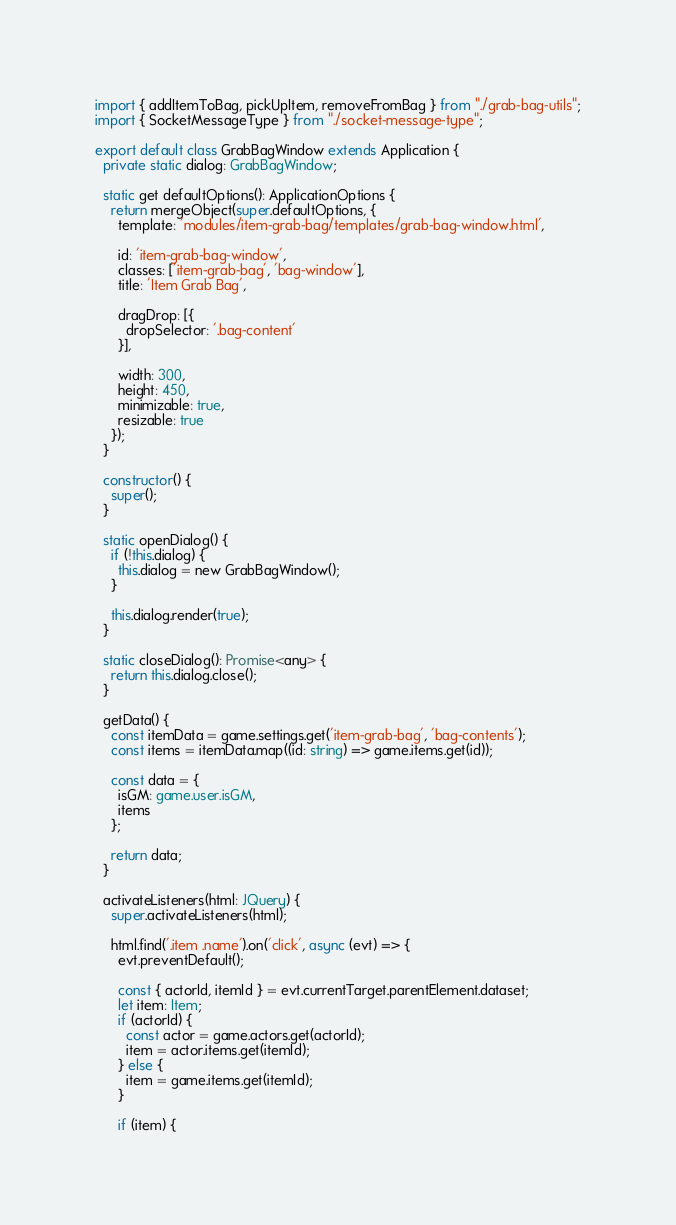Convert code to text. <code><loc_0><loc_0><loc_500><loc_500><_TypeScript_>import { addItemToBag, pickUpItem, removeFromBag } from "./grab-bag-utils";
import { SocketMessageType } from "./socket-message-type";

export default class GrabBagWindow extends Application {
  private static dialog: GrabBagWindow;

  static get defaultOptions(): ApplicationOptions {
    return mergeObject(super.defaultOptions, {
      template: 'modules/item-grab-bag/templates/grab-bag-window.html',

      id: 'item-grab-bag-window',
      classes: ['item-grab-bag', 'bag-window'],
      title: 'Item Grab Bag',

      dragDrop: [{
        dropSelector: '.bag-content'
      }],

      width: 300,
      height: 450,
      minimizable: true,
      resizable: true
    });
  }

  constructor() {
    super();
  }

  static openDialog() {
    if (!this.dialog) {
      this.dialog = new GrabBagWindow();
    }

    this.dialog.render(true);
  }

  static closeDialog(): Promise<any> {
    return this.dialog.close();
  }

  getData() {
    const itemData = game.settings.get('item-grab-bag', 'bag-contents');
    const items = itemData.map((id: string) => game.items.get(id));

    const data = {
      isGM: game.user.isGM,
      items
    };

    return data;
  }

  activateListeners(html: JQuery) {
    super.activateListeners(html);

    html.find('.item .name').on('click', async (evt) => {
      evt.preventDefault();

      const { actorId, itemId } = evt.currentTarget.parentElement.dataset;
      let item: Item;
      if (actorId) {
        const actor = game.actors.get(actorId);
        item = actor.items.get(itemId);
      } else {
        item = game.items.get(itemId);
      }

      if (item) {</code> 